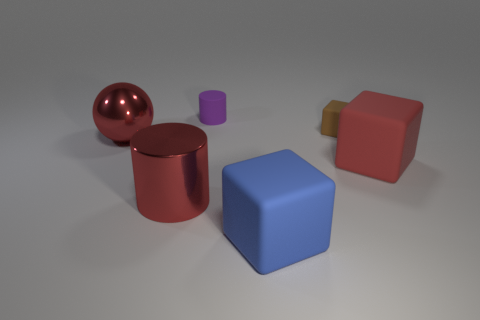Add 4 purple metal blocks. How many objects exist? 10 Subtract all cylinders. How many objects are left? 4 Subtract all big matte things. Subtract all large red matte things. How many objects are left? 3 Add 5 matte cylinders. How many matte cylinders are left? 6 Add 5 red shiny blocks. How many red shiny blocks exist? 5 Subtract 1 blue cubes. How many objects are left? 5 